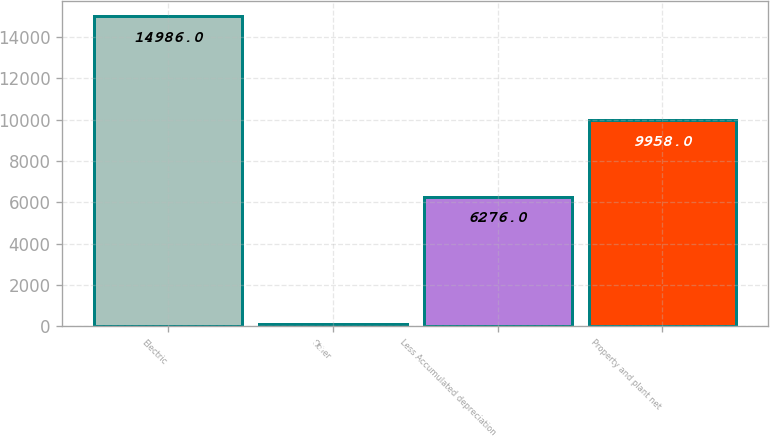<chart> <loc_0><loc_0><loc_500><loc_500><bar_chart><fcel>Electric<fcel>Other<fcel>Less Accumulated depreciation<fcel>Property and plant net<nl><fcel>14986<fcel>113<fcel>6276<fcel>9958<nl></chart> 